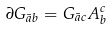Convert formula to latex. <formula><loc_0><loc_0><loc_500><loc_500>\partial G _ { \bar { a } b } = G _ { \bar { a } c } A ^ { c } _ { b }</formula> 